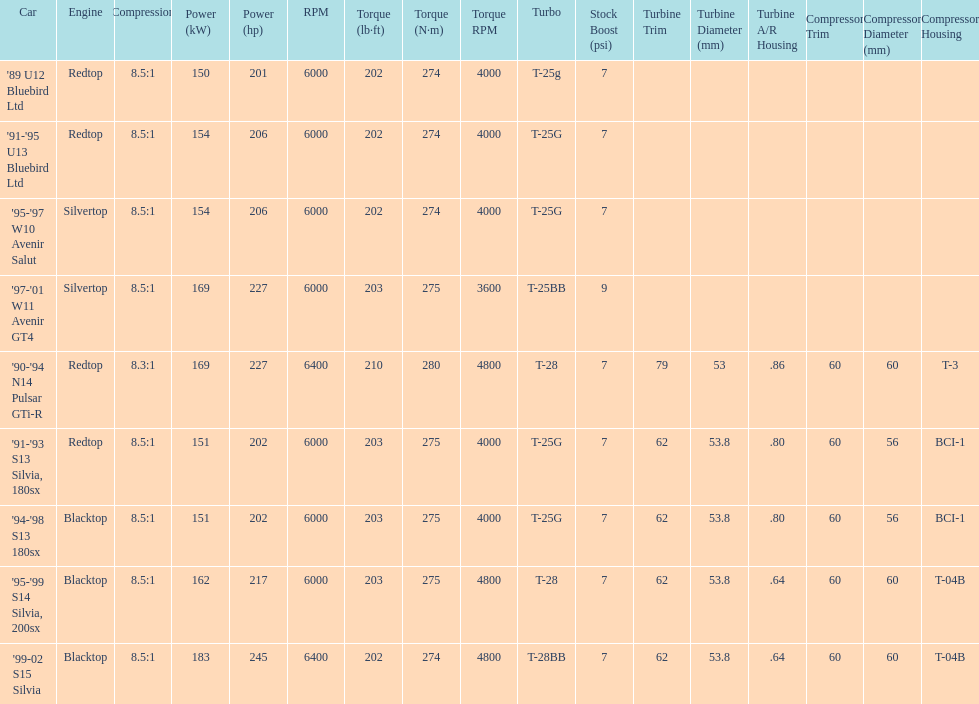How many models used the redtop engine? 4. 